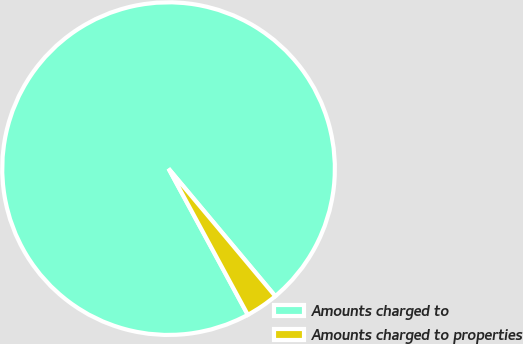<chart> <loc_0><loc_0><loc_500><loc_500><pie_chart><fcel>Amounts charged to<fcel>Amounts charged to properties<nl><fcel>96.82%<fcel>3.18%<nl></chart> 